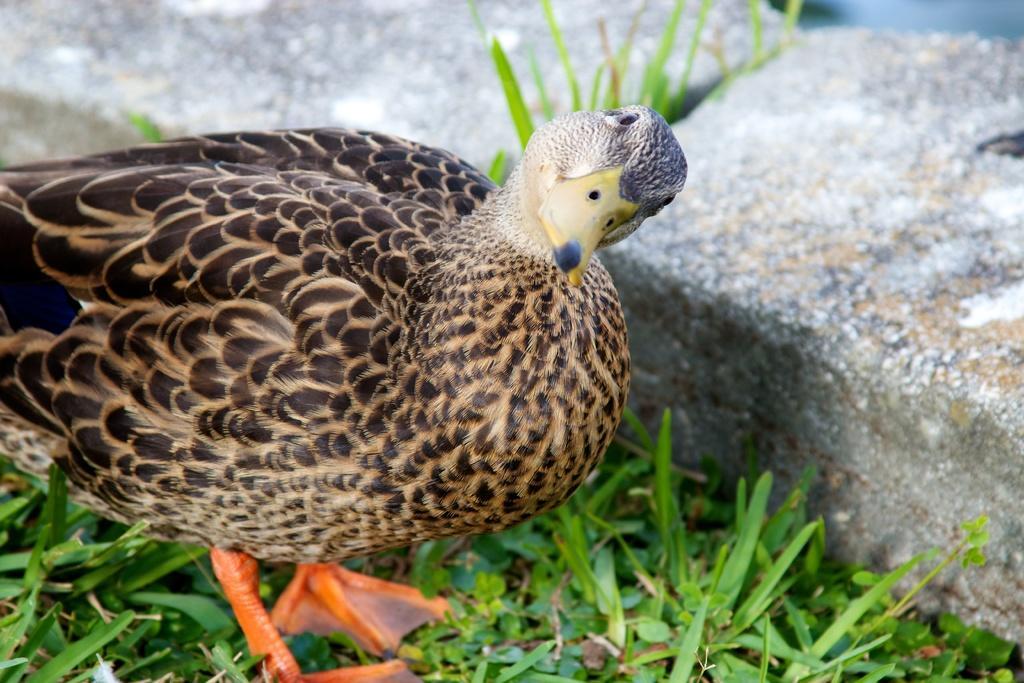Can you describe this image briefly? In the center of the image there is a bird standing on the grass. In the background we can see stones. 